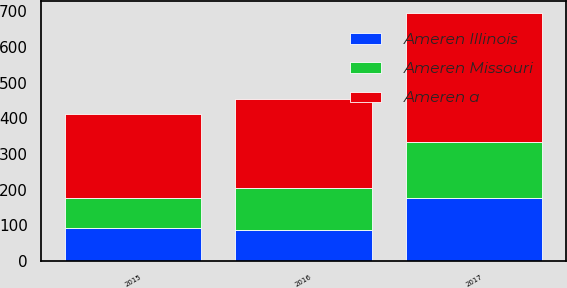<chart> <loc_0><loc_0><loc_500><loc_500><stacked_bar_chart><ecel><fcel>2017<fcel>2016<fcel>2015<nl><fcel>Ameren a<fcel>361<fcel>251<fcel>235<nl><fcel>Ameren Missouri<fcel>159<fcel>116<fcel>85<nl><fcel>Ameren Illinois<fcel>175<fcel>87<fcel>92<nl></chart> 